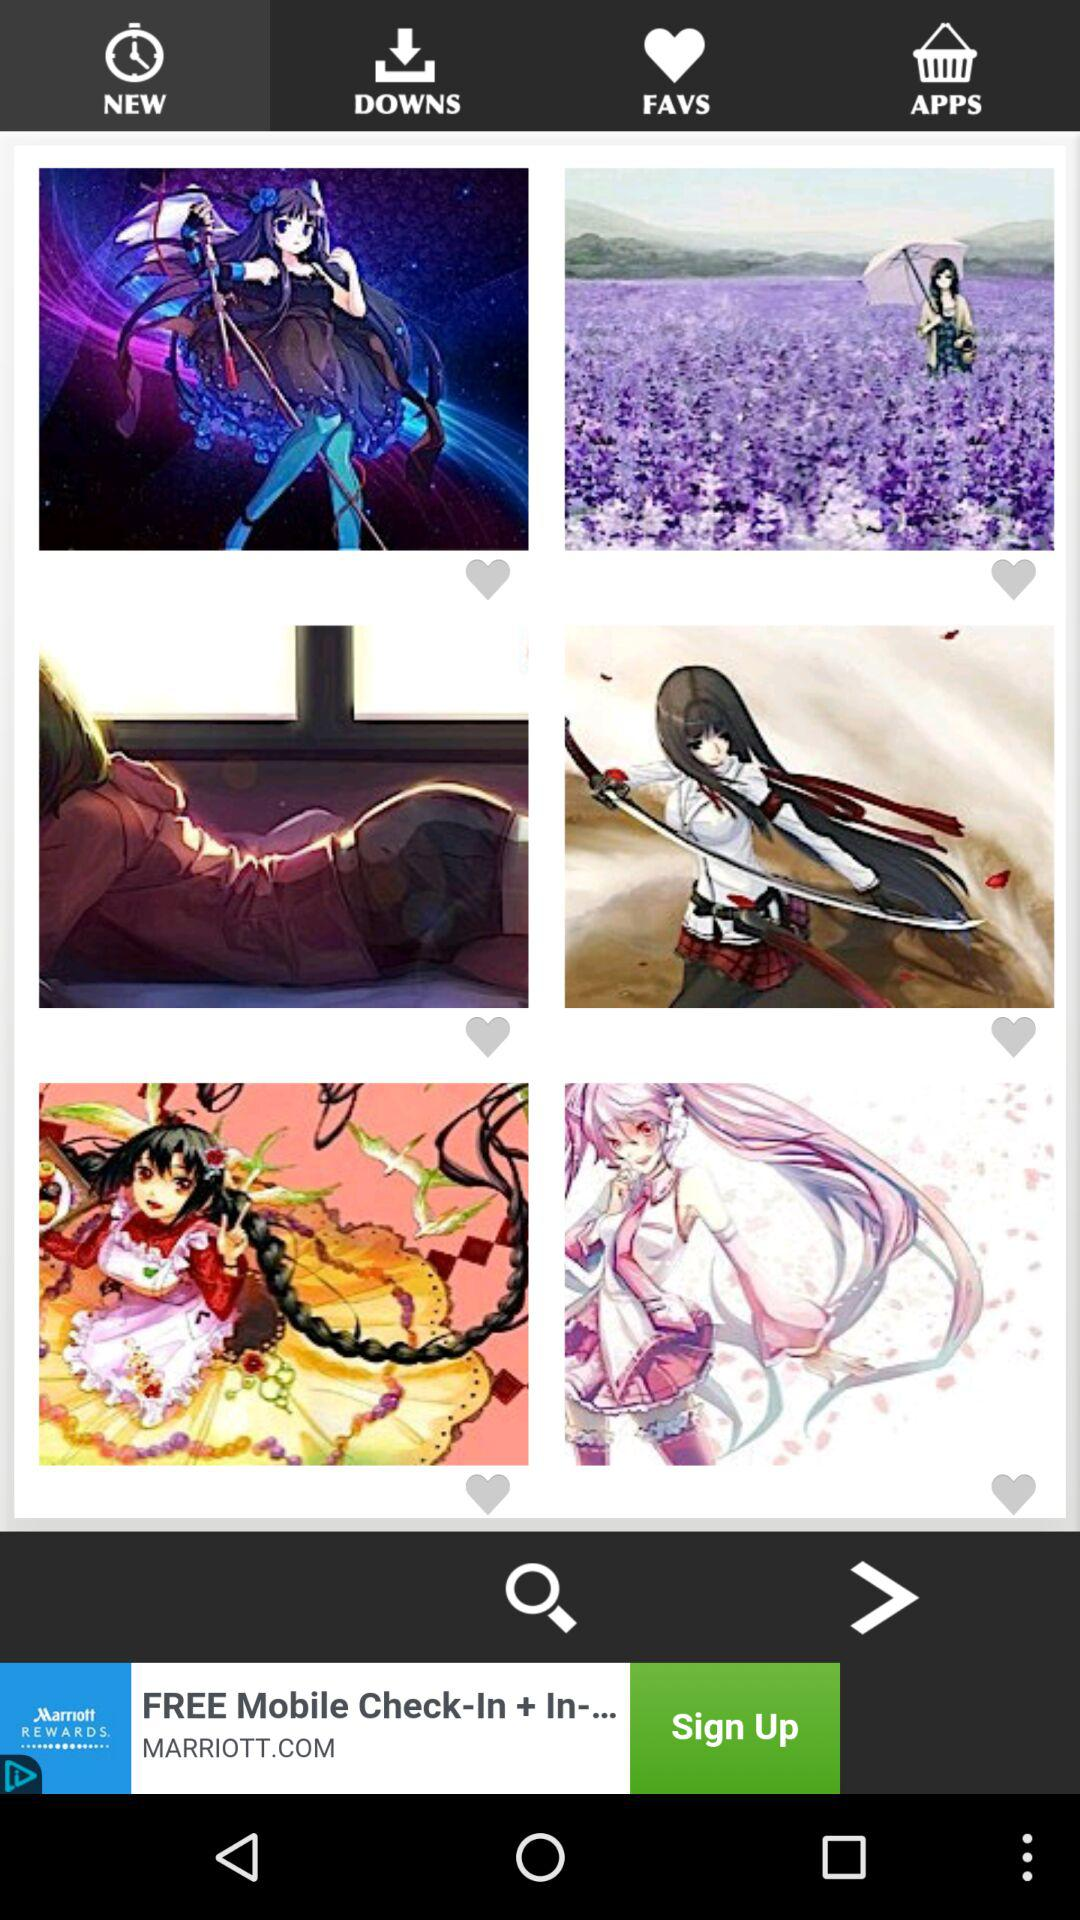Which tab has been selected? The selected tab is "NEW". 